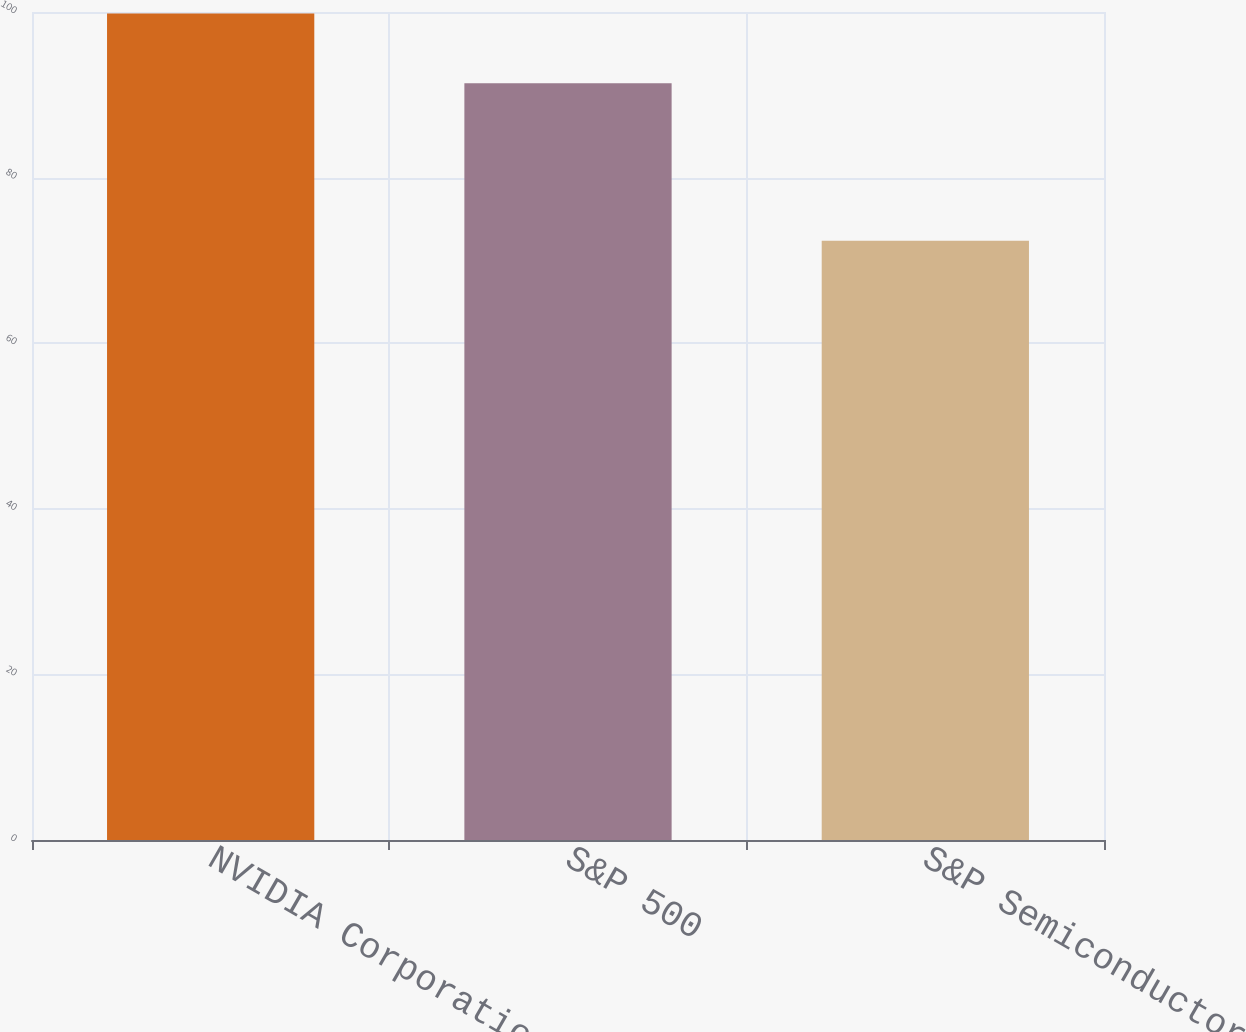Convert chart to OTSL. <chart><loc_0><loc_0><loc_500><loc_500><bar_chart><fcel>NVIDIA Corporation<fcel>S&P 500<fcel>S&P Semiconductors<nl><fcel>99.83<fcel>91.41<fcel>72.37<nl></chart> 